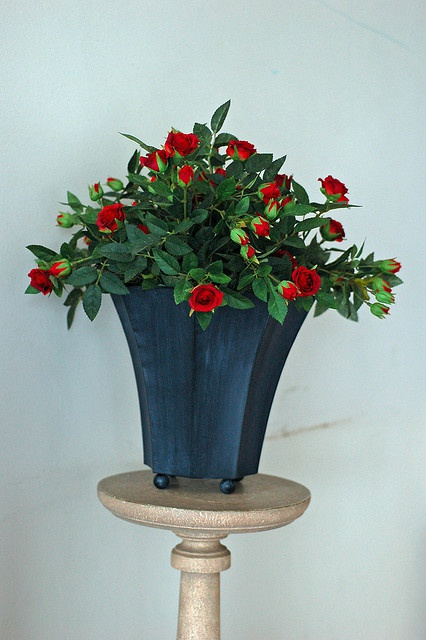Describe the objects in this image and their specific colors. I can see potted plant in lightgray, black, darkgreen, darkblue, and teal tones and vase in lightgray, darkblue, navy, blue, and gray tones in this image. 